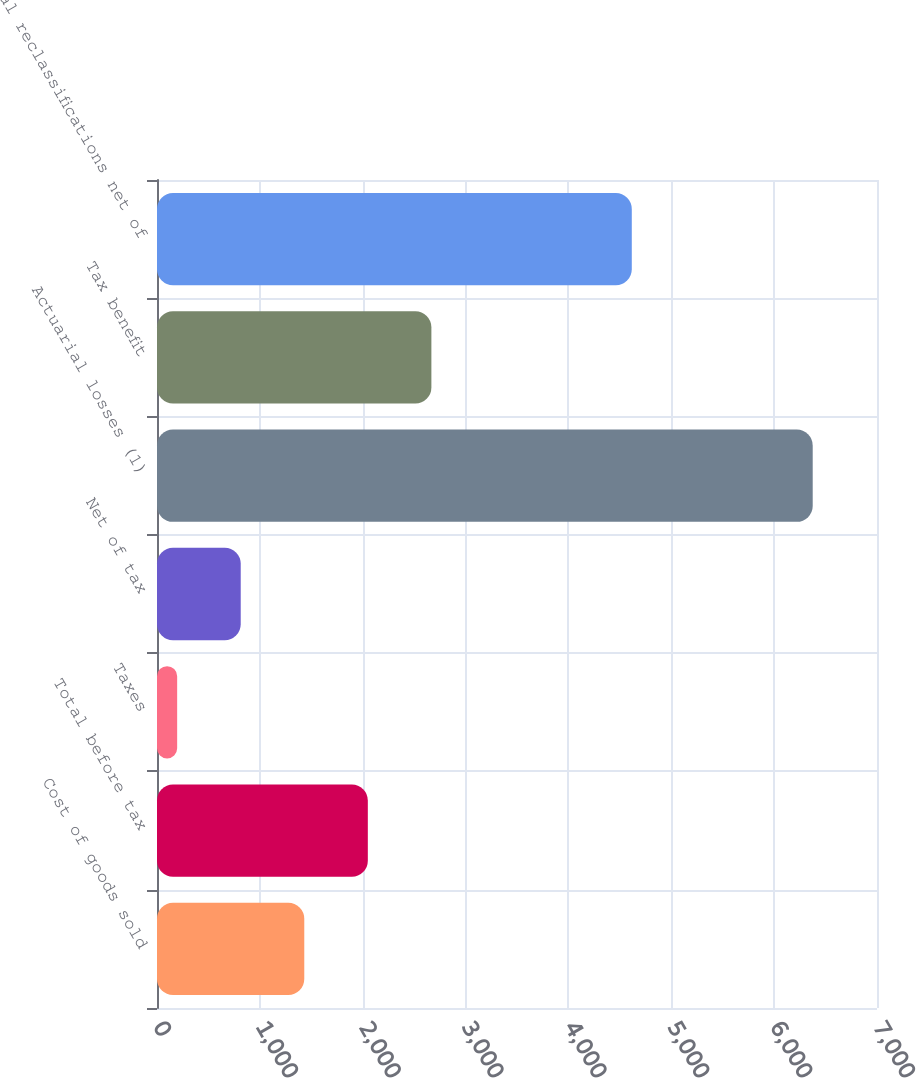<chart> <loc_0><loc_0><loc_500><loc_500><bar_chart><fcel>Cost of goods sold<fcel>Total before tax<fcel>Taxes<fcel>Net of tax<fcel>Actuarial losses (1)<fcel>Tax benefit<fcel>Total reclassifications net of<nl><fcel>1431.8<fcel>2049.7<fcel>196<fcel>813.9<fcel>6375<fcel>2667.6<fcel>4616<nl></chart> 